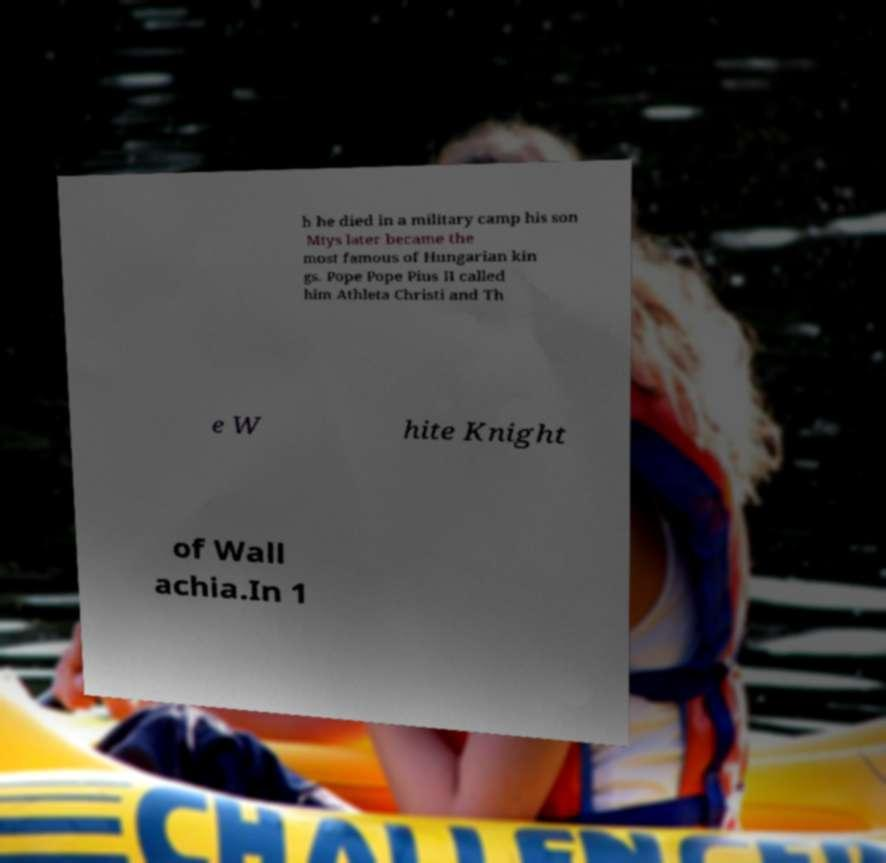Please identify and transcribe the text found in this image. h he died in a military camp his son Mtys later became the most famous of Hungarian kin gs. Pope Pope Pius II called him Athleta Christi and Th e W hite Knight of Wall achia.In 1 